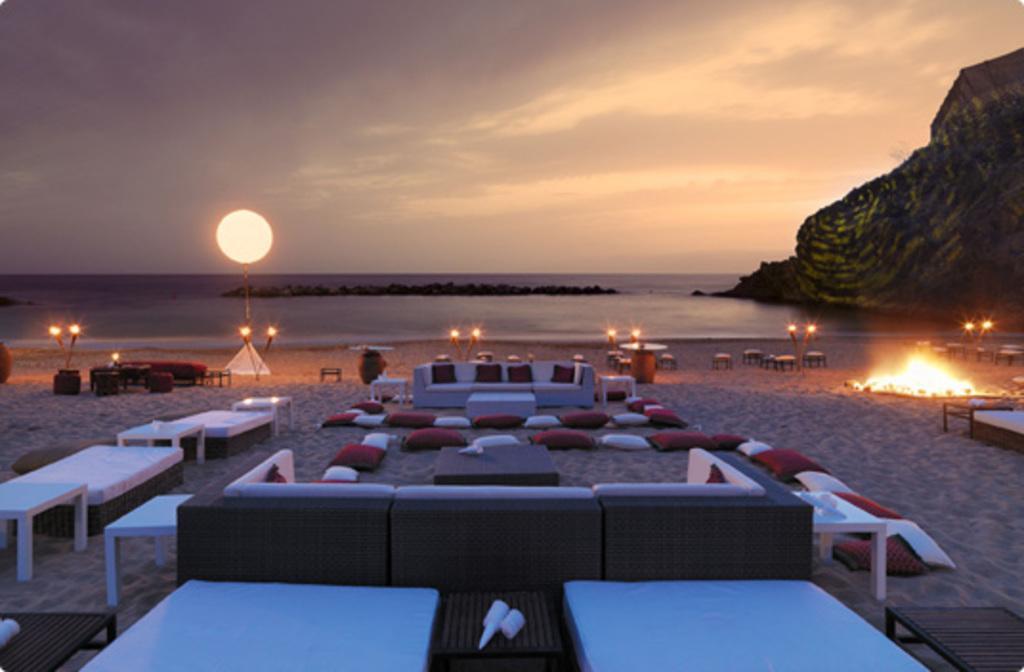Can you describe this image briefly? In this image we can see tables, sofas and cushions placed on the seashore and there are lights. In the background there is a sea, hills and sky. 